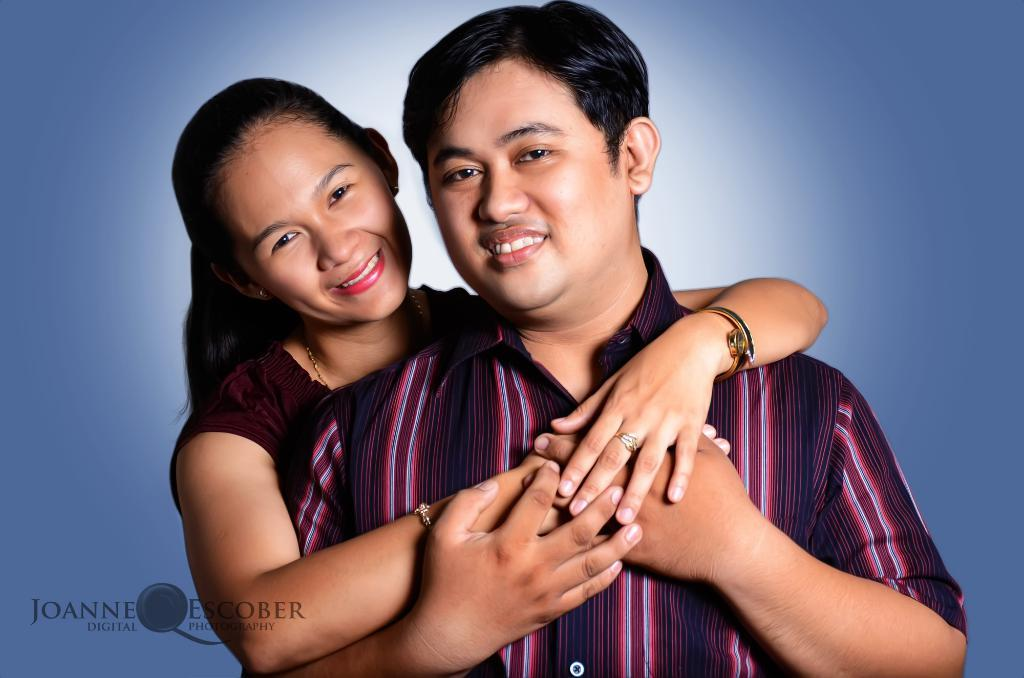How many people are in the image? There are two persons in the image. What is the facial expression of the persons? The persons have smiling faces. What are the persons doing in the image? The persons are holding each other. What can be seen on the bottom left side of the image? There is some text on the bottom left side of the image. What is the color of the background in the image? The background of the image is light blue in color. What type of vessel is being used by the persons in the image? There is no vessel present in the image; the persons are holding each other. What territory is depicted in the image? The image does not depict any specific territory; it focuses on the two persons and their interaction. 